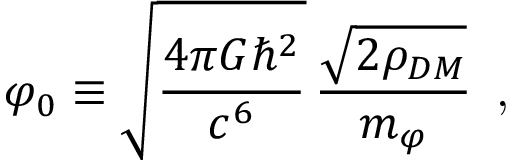Convert formula to latex. <formula><loc_0><loc_0><loc_500><loc_500>\varphi _ { 0 } \equiv \sqrt { \frac { 4 \pi G \hbar { ^ } { 2 } } { c ^ { 6 } } } \, \frac { \sqrt { 2 \rho _ { D M } } } { m _ { \varphi } } \, ,</formula> 